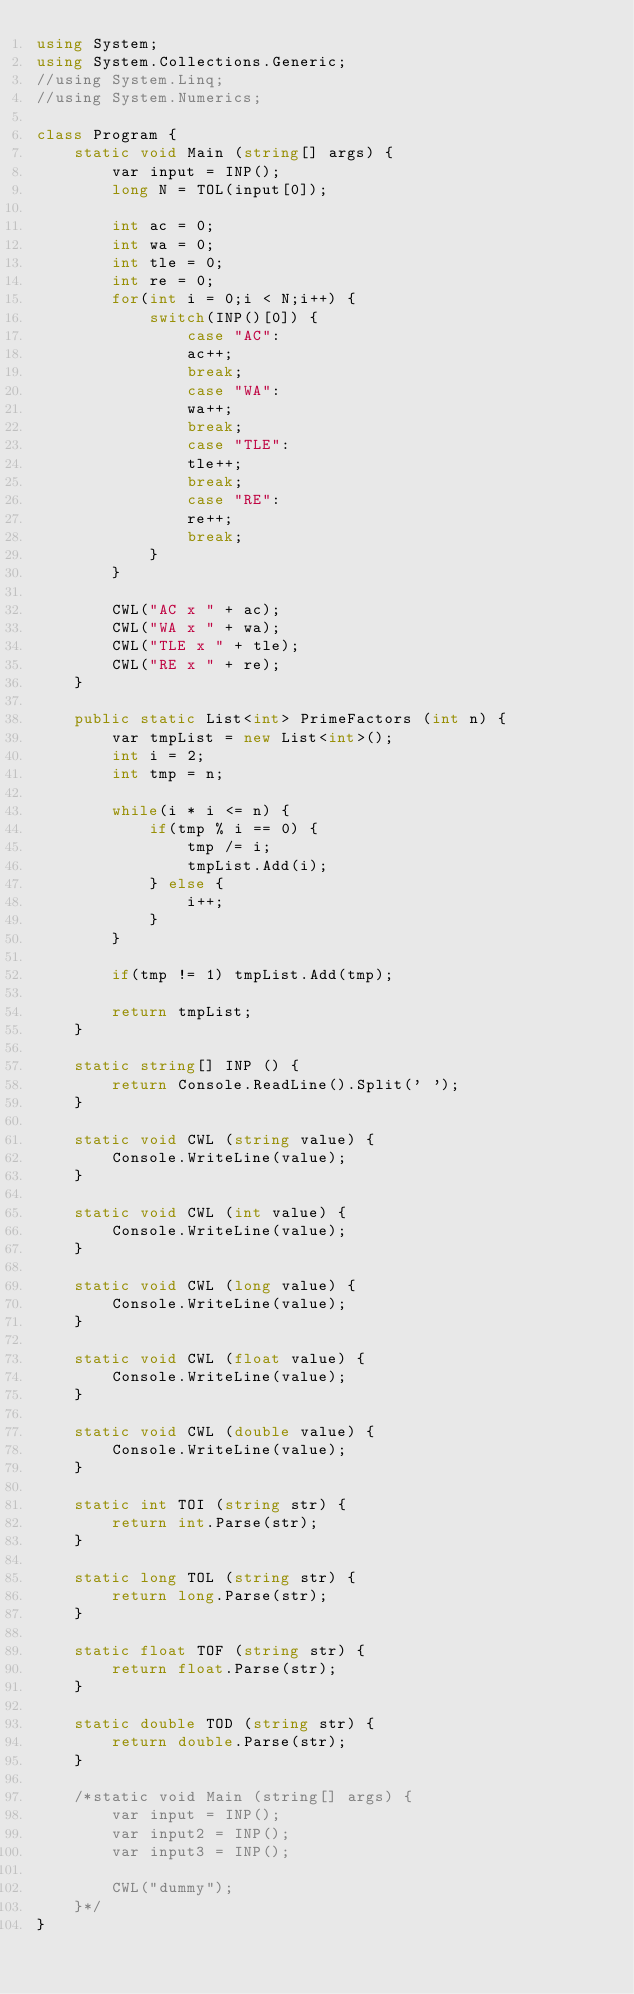<code> <loc_0><loc_0><loc_500><loc_500><_C#_>using System;
using System.Collections.Generic;
//using System.Linq;
//using System.Numerics;

class Program {
    static void Main (string[] args) {
        var input = INP();
        long N = TOL(input[0]);

        int ac = 0;
        int wa = 0;
        int tle = 0;
        int re = 0;
        for(int i = 0;i < N;i++) {
            switch(INP()[0]) {
                case "AC":
                ac++;
                break;
                case "WA":
                wa++;
                break;
                case "TLE":
                tle++;
                break;
                case "RE":
                re++;
                break;
            }
        }

        CWL("AC x " + ac);
        CWL("WA x " + wa);
        CWL("TLE x " + tle);
        CWL("RE x " + re);
    }

    public static List<int> PrimeFactors (int n) {
        var tmpList = new List<int>();
        int i = 2;
        int tmp = n;

        while(i * i <= n) {
            if(tmp % i == 0) {
                tmp /= i;
                tmpList.Add(i);
            } else {
                i++;
            }
        }

        if(tmp != 1) tmpList.Add(tmp);

        return tmpList;
    }

    static string[] INP () {
        return Console.ReadLine().Split(' ');
    }

    static void CWL (string value) {
        Console.WriteLine(value);
    }

    static void CWL (int value) {
        Console.WriteLine(value);
    }

    static void CWL (long value) {
        Console.WriteLine(value);
    }

    static void CWL (float value) {
        Console.WriteLine(value);
    }

    static void CWL (double value) {
        Console.WriteLine(value);
    }

    static int TOI (string str) {
        return int.Parse(str);
    }

    static long TOL (string str) {
        return long.Parse(str);
    }

    static float TOF (string str) {
        return float.Parse(str);
    }

    static double TOD (string str) {
        return double.Parse(str);
    }

    /*static void Main (string[] args) {
        var input = INP();
        var input2 = INP();
        var input3 = INP();

        CWL("dummy");
    }*/
}
</code> 